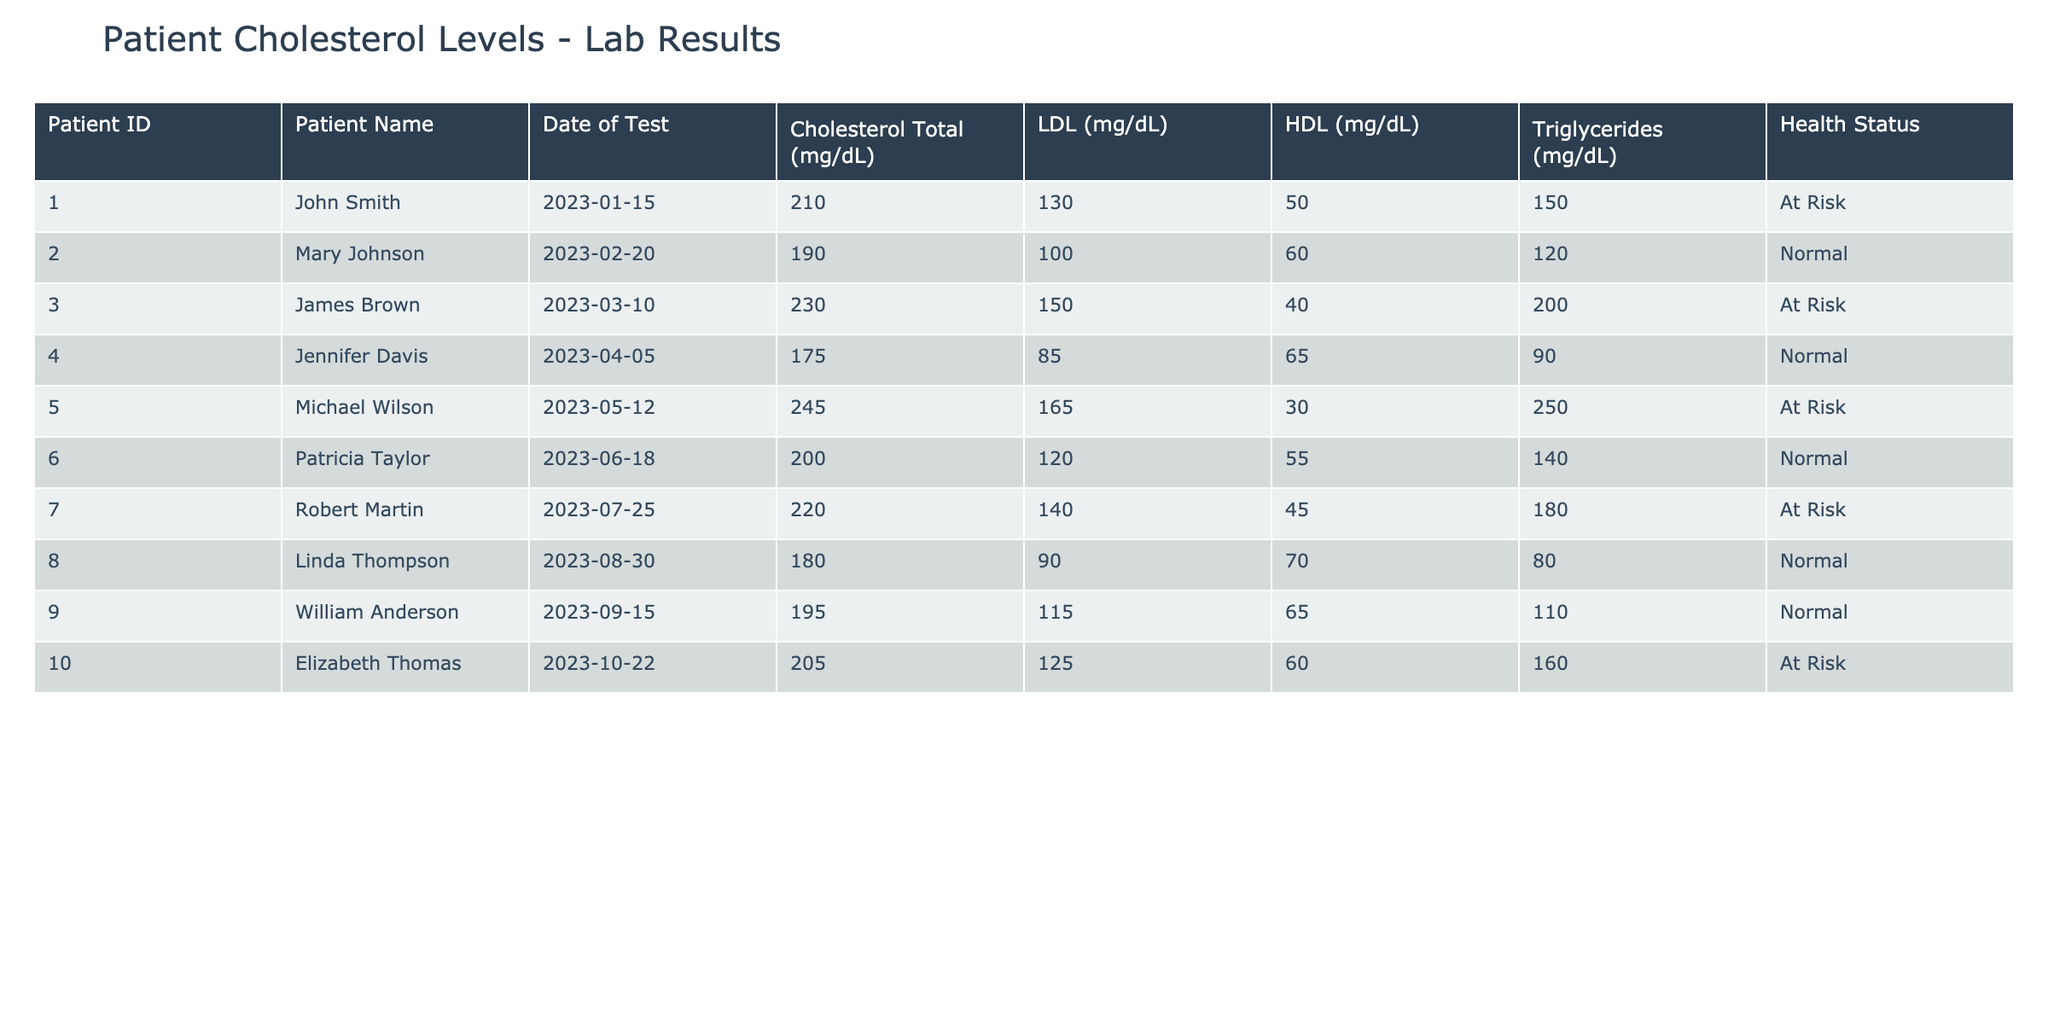What is the cholesterol level of Mary Johnson? The table shows that Mary Johnson has a total cholesterol level of 190 mg/dL as recorded on February 20, 2023.
Answer: 190 mg/dL How many patients are classified as "At Risk"? By reviewing the health status column, I can see that the patients classified as "At Risk" are John Smith, James Brown, Michael Wilson, Robert Martin, and Elizabeth Thomas, totaling 5 patients.
Answer: 5 What is the average LDL cholesterol level for all patients in the table? First, I sum up the LDL levels: 130 + 100 + 150 + 85 + 165 + 120 + 140 + 90 + 115 + 125 = 1,220. There are 10 patients, so I divide 1,220 by 10, which gives an average of 122 mg/dL.
Answer: 122 mg/dL Is there any patient with a total cholesterol level below 180 mg/dL? I look at the cholesterol levels and find that only Jennifer Davis has a level of 175 mg/dL, which is below 180 mg/dL. Thus, the answer is yes.
Answer: Yes Which patient has the highest triglycerides level, and what is that level? Examining the triglycerides column, I see that Michael Wilson has the highest level at 250 mg/dL as noted in his record on May 12, 2023.
Answer: Michael Wilson, 250 mg/dL What is the difference in total cholesterol levels between the highest and lowest values? The highest total cholesterol level is from Michael Wilson at 245 mg/dL and the lowest is from Jennifer Davis at 175 mg/dL. So, the difference is 245 - 175 = 70 mg/dL.
Answer: 70 mg/dL How many patients have HDL cholesterol levels greater than 60 mg/dL? Looking at the HDL levels, I see that Mary Johnson, Jennifer Davis, and William Anderson have levels greater than 60 mg/dL. That totals 3 patients with such levels.
Answer: 3 Are there any patients who have a "Normal" health status with LDL cholesterol levels higher than 120 mg/dL? Checking the "Normal" health status patients, I find that Patricia Taylor (120 mg/dL) and William Anderson (115 mg/dL) do not exceed 120 mg/dL. So, there are no patients who meet the criteria.
Answer: No What is the health status of the patient with the lowest HDL cholesterol level? The patient with the lowest HDL is Michael Wilson at 30 mg/dL, and his health status is "At Risk."
Answer: At Risk 